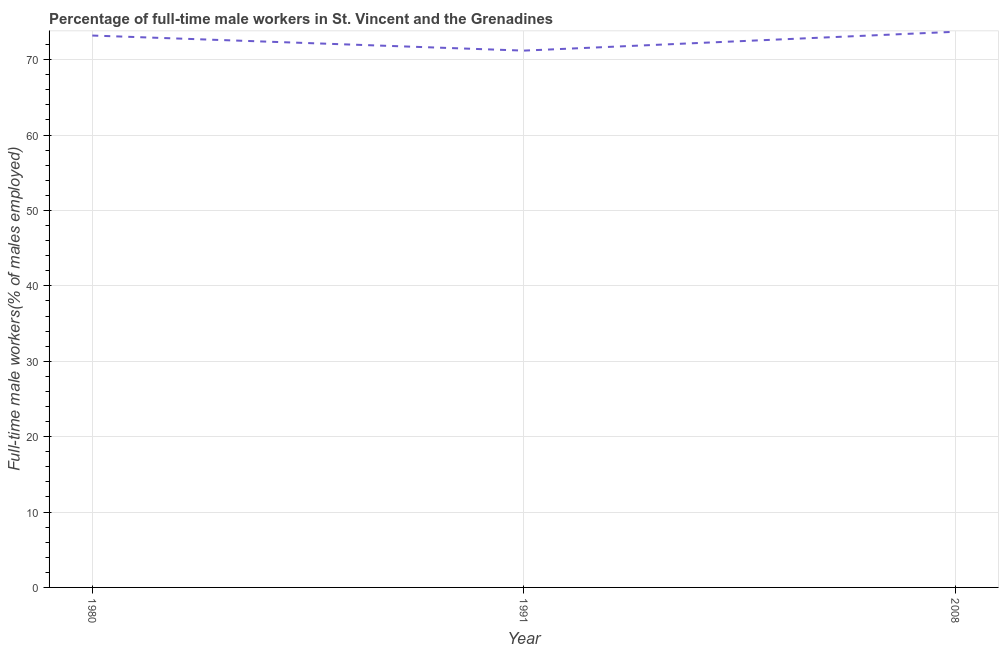What is the percentage of full-time male workers in 1991?
Offer a terse response. 71.2. Across all years, what is the maximum percentage of full-time male workers?
Offer a terse response. 73.7. Across all years, what is the minimum percentage of full-time male workers?
Provide a short and direct response. 71.2. In which year was the percentage of full-time male workers maximum?
Offer a very short reply. 2008. What is the sum of the percentage of full-time male workers?
Your response must be concise. 218.1. What is the difference between the percentage of full-time male workers in 1980 and 1991?
Provide a succinct answer. 2. What is the average percentage of full-time male workers per year?
Ensure brevity in your answer.  72.7. What is the median percentage of full-time male workers?
Ensure brevity in your answer.  73.2. What is the ratio of the percentage of full-time male workers in 1991 to that in 2008?
Give a very brief answer. 0.97. Is the difference between the percentage of full-time male workers in 1991 and 2008 greater than the difference between any two years?
Provide a succinct answer. Yes. What is the difference between the highest and the lowest percentage of full-time male workers?
Your response must be concise. 2.5. In how many years, is the percentage of full-time male workers greater than the average percentage of full-time male workers taken over all years?
Provide a succinct answer. 2. How many lines are there?
Your answer should be very brief. 1. How many years are there in the graph?
Ensure brevity in your answer.  3. What is the difference between two consecutive major ticks on the Y-axis?
Offer a terse response. 10. Does the graph contain any zero values?
Give a very brief answer. No. Does the graph contain grids?
Give a very brief answer. Yes. What is the title of the graph?
Your answer should be very brief. Percentage of full-time male workers in St. Vincent and the Grenadines. What is the label or title of the Y-axis?
Your answer should be very brief. Full-time male workers(% of males employed). What is the Full-time male workers(% of males employed) of 1980?
Ensure brevity in your answer.  73.2. What is the Full-time male workers(% of males employed) of 1991?
Offer a very short reply. 71.2. What is the Full-time male workers(% of males employed) in 2008?
Offer a terse response. 73.7. What is the difference between the Full-time male workers(% of males employed) in 1980 and 1991?
Keep it short and to the point. 2. What is the difference between the Full-time male workers(% of males employed) in 1980 and 2008?
Provide a succinct answer. -0.5. What is the difference between the Full-time male workers(% of males employed) in 1991 and 2008?
Offer a terse response. -2.5. What is the ratio of the Full-time male workers(% of males employed) in 1980 to that in 1991?
Give a very brief answer. 1.03. What is the ratio of the Full-time male workers(% of males employed) in 1991 to that in 2008?
Offer a very short reply. 0.97. 